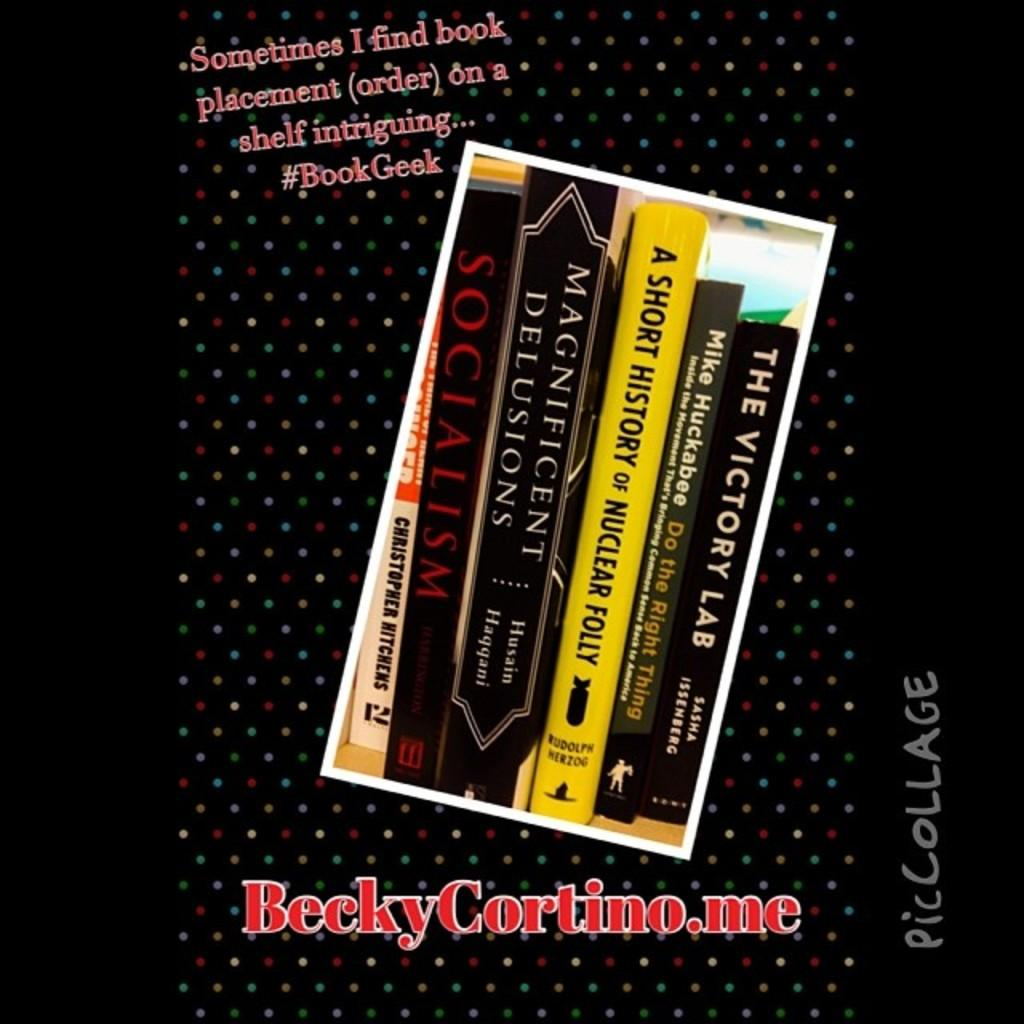<image>
Present a compact description of the photo's key features. A row of books including A Short History of Nuclear Folly. 